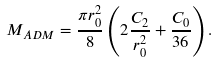Convert formula to latex. <formula><loc_0><loc_0><loc_500><loc_500>M _ { A D M } = \frac { \pi r _ { 0 } ^ { 2 } } { 8 } \left ( 2 \frac { C _ { 2 } } { r _ { 0 } ^ { 2 } } + \frac { C _ { 0 } } { 3 6 } \right ) .</formula> 